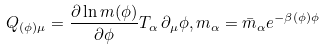<formula> <loc_0><loc_0><loc_500><loc_500>Q _ { ( \phi ) \mu } = \frac { \partial \ln { m ( \phi ) } } { \partial \phi } T _ { \alpha } \, \partial _ { \mu } \phi , m _ { \alpha } = \bar { m } _ { \alpha } e ^ { - { \beta ( \phi ) } { \phi } }</formula> 